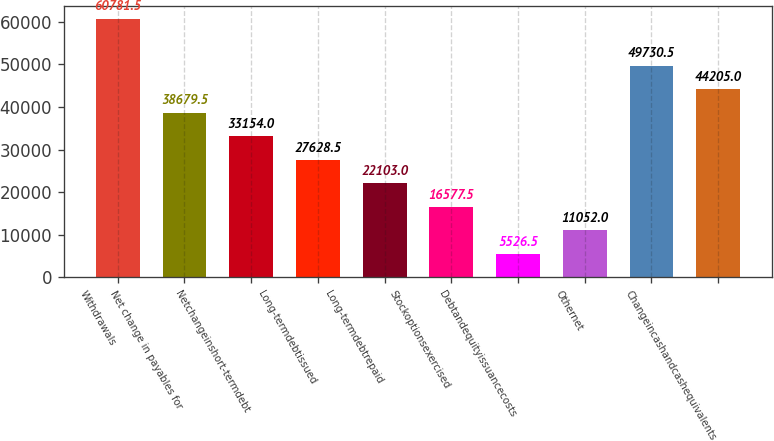Convert chart to OTSL. <chart><loc_0><loc_0><loc_500><loc_500><bar_chart><fcel>Withdrawals<fcel>Net change in payables for<fcel>Netchangeinshort-termdebt<fcel>Long-termdebtissued<fcel>Long-termdebtrepaid<fcel>Stockoptionsexercised<fcel>Debtandequityissuancecosts<fcel>Othernet<fcel>Unnamed: 8<fcel>Changeincashandcashequivalents<nl><fcel>60781.5<fcel>38679.5<fcel>33154<fcel>27628.5<fcel>22103<fcel>16577.5<fcel>5526.5<fcel>11052<fcel>49730.5<fcel>44205<nl></chart> 